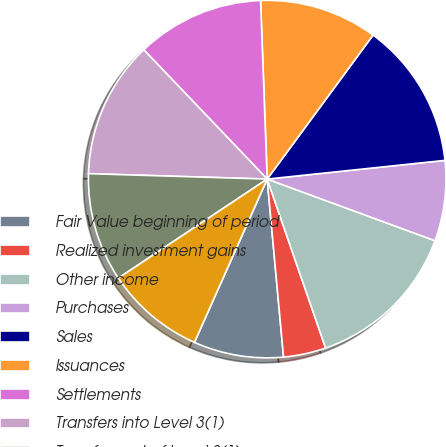<chart> <loc_0><loc_0><loc_500><loc_500><pie_chart><fcel>Fair Value beginning of period<fcel>Realized investment gains<fcel>Other income<fcel>Purchases<fcel>Sales<fcel>Issuances<fcel>Settlements<fcel>Transfers into Level 3(1)<fcel>Transfers out of Level 3(1)<fcel>Fair Value end of period<nl><fcel>8.13%<fcel>3.84%<fcel>14.1%<fcel>7.27%<fcel>13.24%<fcel>10.68%<fcel>11.54%<fcel>12.39%<fcel>9.83%<fcel>8.98%<nl></chart> 